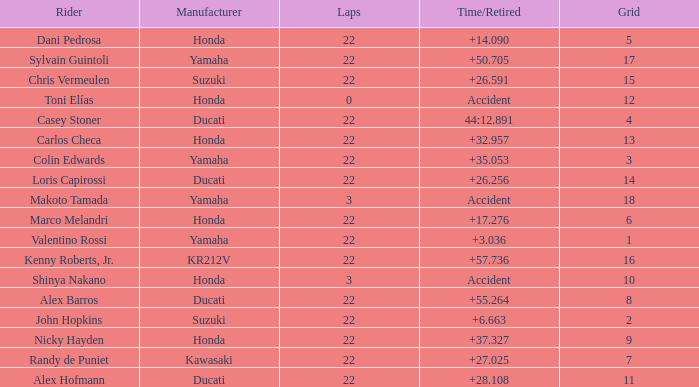What was the average amount of laps for competitors with a grid that was more than 11 and a Time/Retired of +28.108? None. 